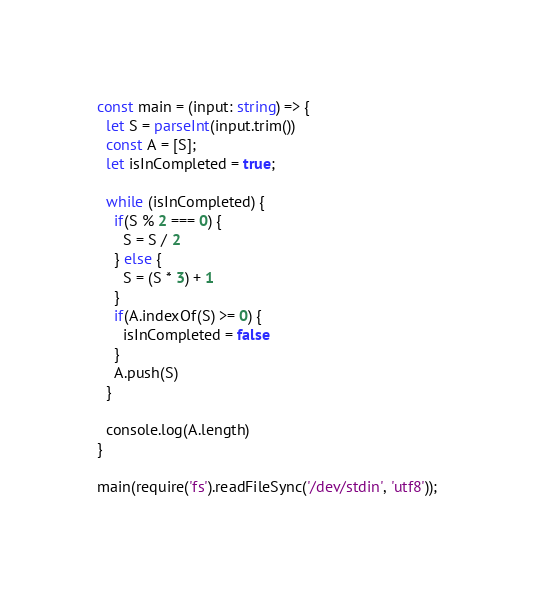Convert code to text. <code><loc_0><loc_0><loc_500><loc_500><_TypeScript_>const main = (input: string) => {
  let S = parseInt(input.trim())
  const A = [S];
  let isInCompleted = true;

  while (isInCompleted) {
    if(S % 2 === 0) {
      S = S / 2
    } else {
      S = (S * 3) + 1
    }
    if(A.indexOf(S) >= 0) {
      isInCompleted = false
    }
    A.push(S)
  }

  console.log(A.length)
}

main(require('fs').readFileSync('/dev/stdin', 'utf8'));
</code> 